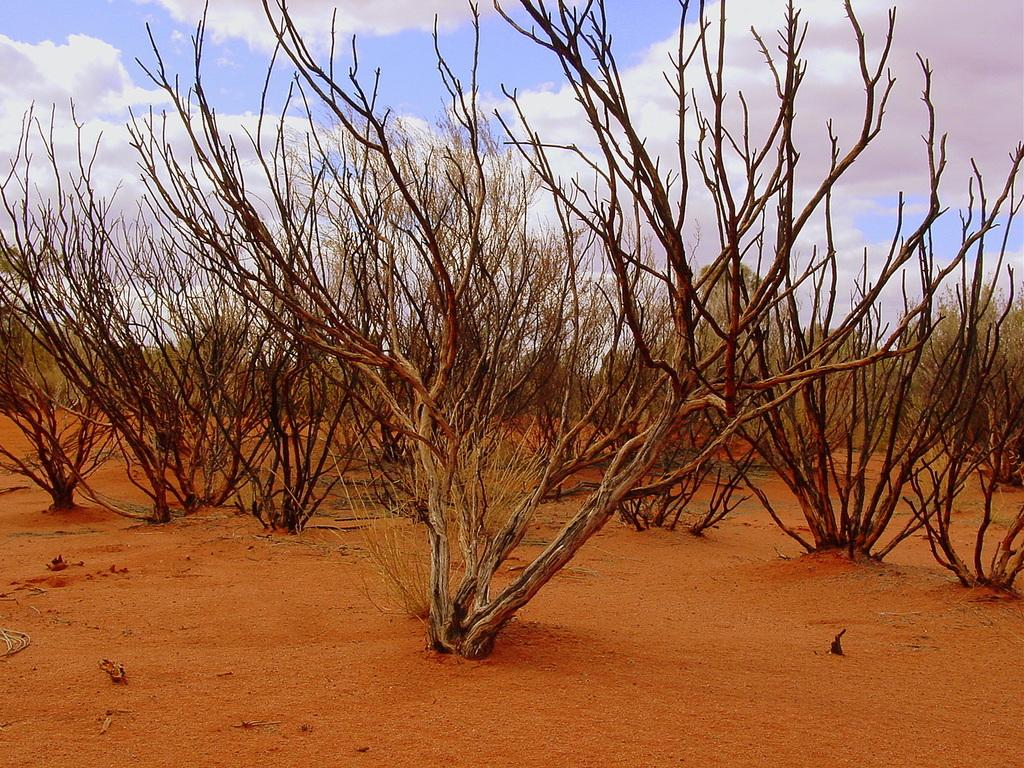What is the color of the ground in the image? The ground in the image is brown in color. What can be seen on the ground in the image? There are dried trees on the ground. What is visible in the background of the image? The sky is visible in the background of the image. What type of story is being told by the cherry in the image? There is no cherry present in the image, so no story can be told by a cherry. Can you see a nest in the image? There is no nest visible in the image. 